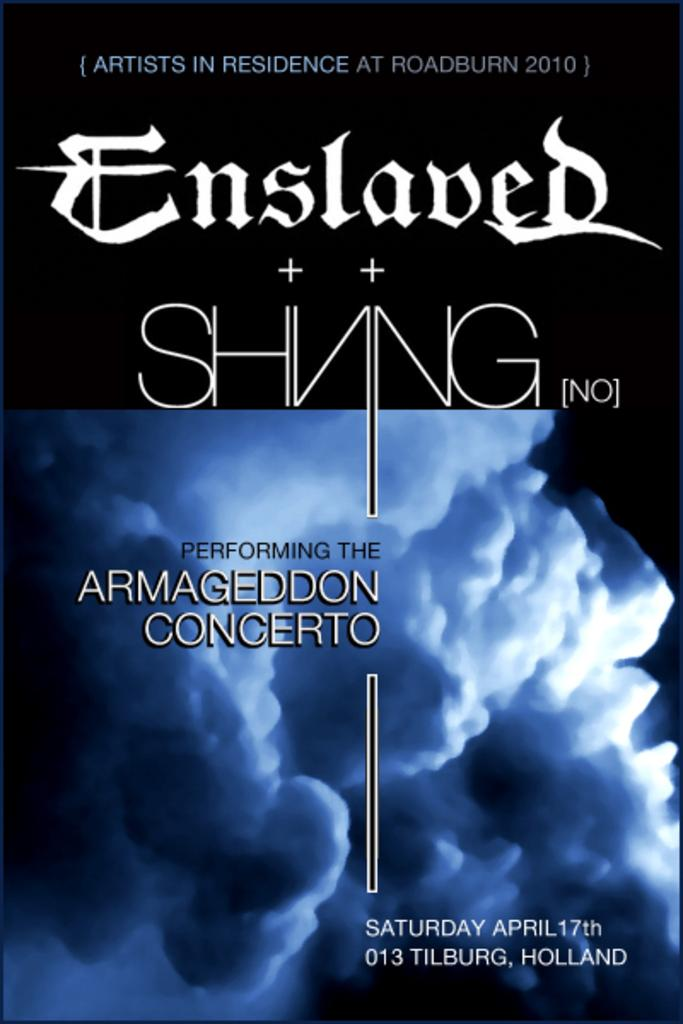<image>
Offer a succinct explanation of the picture presented. A program front cover announcing the performance of Armageddon Concerto. 